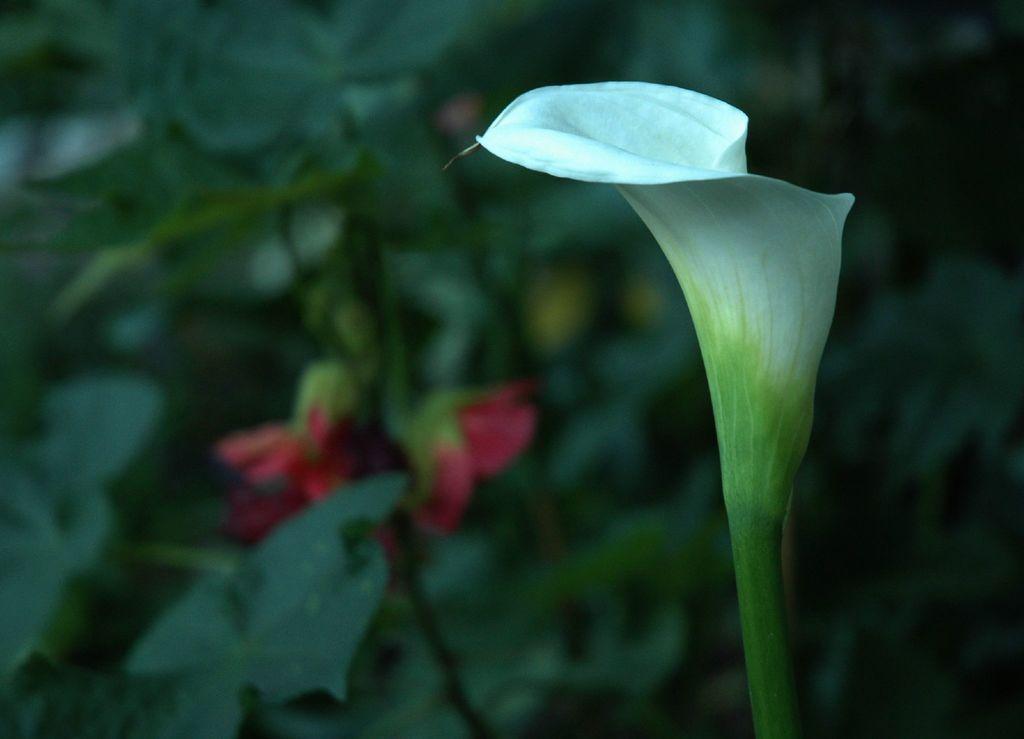Can you describe this image briefly? In front of the picture, we see the flower in white color. In the background, we see the plants and the flowers in red color. This picture is blurred in the background. 